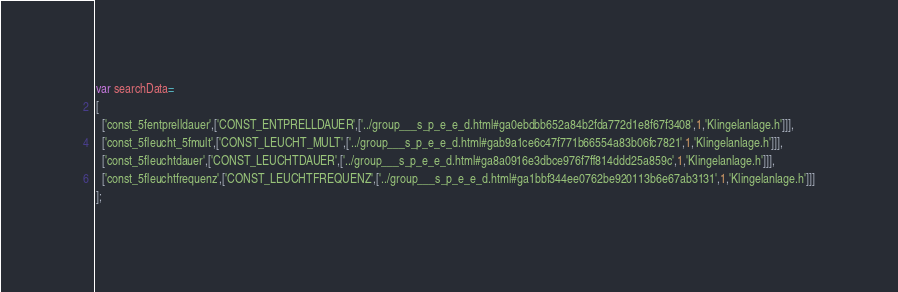Convert code to text. <code><loc_0><loc_0><loc_500><loc_500><_JavaScript_>var searchData=
[
  ['const_5fentprelldauer',['CONST_ENTPRELLDAUER',['../group___s_p_e_e_d.html#ga0ebdbb652a84b2fda772d1e8f67f3408',1,'Klingelanlage.h']]],
  ['const_5fleucht_5fmult',['CONST_LEUCHT_MULT',['../group___s_p_e_e_d.html#gab9a1ce6c47f771b66554a83b06fc7821',1,'Klingelanlage.h']]],
  ['const_5fleuchtdauer',['CONST_LEUCHTDAUER',['../group___s_p_e_e_d.html#ga8a0916e3dbce976f7ff814ddd25a859c',1,'Klingelanlage.h']]],
  ['const_5fleuchtfrequenz',['CONST_LEUCHTFREQUENZ',['../group___s_p_e_e_d.html#ga1bbf344ee0762be920113b6e67ab3131',1,'Klingelanlage.h']]]
];
</code> 